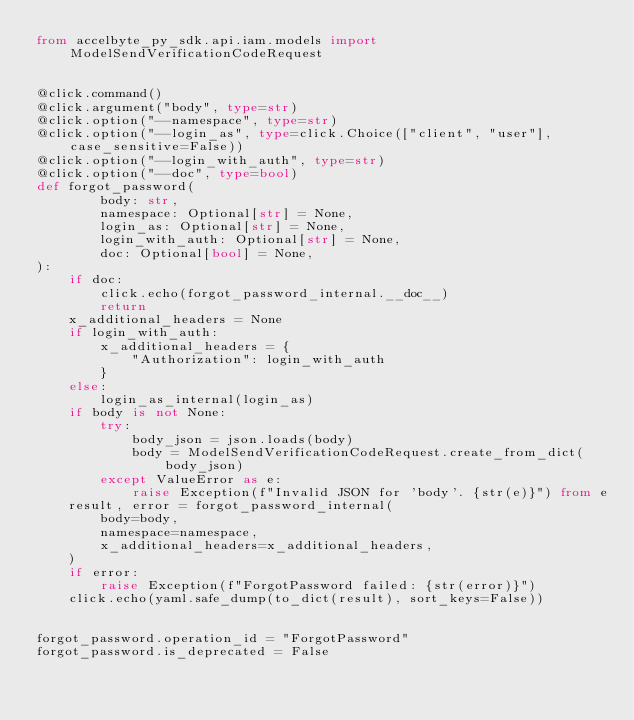<code> <loc_0><loc_0><loc_500><loc_500><_Python_>from accelbyte_py_sdk.api.iam.models import ModelSendVerificationCodeRequest


@click.command()
@click.argument("body", type=str)
@click.option("--namespace", type=str)
@click.option("--login_as", type=click.Choice(["client", "user"], case_sensitive=False))
@click.option("--login_with_auth", type=str)
@click.option("--doc", type=bool)
def forgot_password(
        body: str,
        namespace: Optional[str] = None,
        login_as: Optional[str] = None,
        login_with_auth: Optional[str] = None,
        doc: Optional[bool] = None,
):
    if doc:
        click.echo(forgot_password_internal.__doc__)
        return
    x_additional_headers = None
    if login_with_auth:
        x_additional_headers = {
            "Authorization": login_with_auth
        }
    else:
        login_as_internal(login_as)
    if body is not None:
        try:
            body_json = json.loads(body)
            body = ModelSendVerificationCodeRequest.create_from_dict(body_json)
        except ValueError as e:
            raise Exception(f"Invalid JSON for 'body'. {str(e)}") from e
    result, error = forgot_password_internal(
        body=body,
        namespace=namespace,
        x_additional_headers=x_additional_headers,
    )
    if error:
        raise Exception(f"ForgotPassword failed: {str(error)}")
    click.echo(yaml.safe_dump(to_dict(result), sort_keys=False))


forgot_password.operation_id = "ForgotPassword"
forgot_password.is_deprecated = False
</code> 